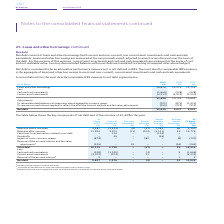According to Bt Group Plc's financial document, How is net debt calculated? loans and other borrowings (both current and non-current), less current asset investments and cash and cash equivalents. The document states: "Net debt Net debt consists of loans and other borrowings (both current and non-current), less current asset investments and cash and cash equivalents...." Also, What was the Loans and other borrowings in 2019, 2018 and 2017? The document contains multiple relevant values: 16,876, 14,275, 12,713 (in millions). From the document: "Loans and other borrowings 16,876 14,275 12,713 Less: Cash and cash equivalents (1,666) (528) (528) Current asset investments (3,214) Loans and other ..." Also, For what years are information about  Loans and other borrowings provided? The document contains multiple relevant values: 2019, 2018, 2017. From the document: "At 31 March 2019 £m 2018 £m 2017 £m At 31 March 2019 £m 2018 £m 2017 £m At 31 March 2019 £m 2018 £m 2017 £m..." Also, can you calculate: What was the change in the Loans and other borrowings from 2018 to 2019? Based on the calculation: 16,876 - 14,275, the result is 2601 (in millions). This is based on the information: "Loans and other borrowings 16,876 14,275 12,713 Less: Cash and cash equivalents (1,666) (528) (528) Current asset investments (3,214) Loans and other borrowings 16,876 14,275 12,713 Less: Cash and cas..." The key data points involved are: 14,275, 16,876. Also, can you calculate: What is the average Cash and cash equivalents for 2017-2019? To answer this question, I need to perform calculations using the financial data. The calculation is: -(1,666 + 528 + 528) / 3, which equals -907.33 (in millions). This is based on the information: "5 12,713 Less: Cash and cash equivalents (1,666) (528) (528) Current asset investments (3,214) (3,022) (1,520) 76 14,275 12,713 Less: Cash and cash equivalents (1,666) (528) (528) Current asset invest..." The key data points involved are: 1,666, 528. Also, can you calculate: What is the percentage change in the Net debt from 2018 to 2019? To answer this question, I need to perform calculations using the financial data. The calculation is: 11,035 / 9,627 - 1, which equals 14.63 (percentage). This is based on the information: "Net debt 11,035 9,627 8,932 Net debt 11,035 9,627 8,932..." The key data points involved are: 11,035, 9,627. 